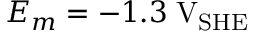Convert formula to latex. <formula><loc_0><loc_0><loc_500><loc_500>E _ { m } = - 1 . 3 \, V _ { S H E }</formula> 